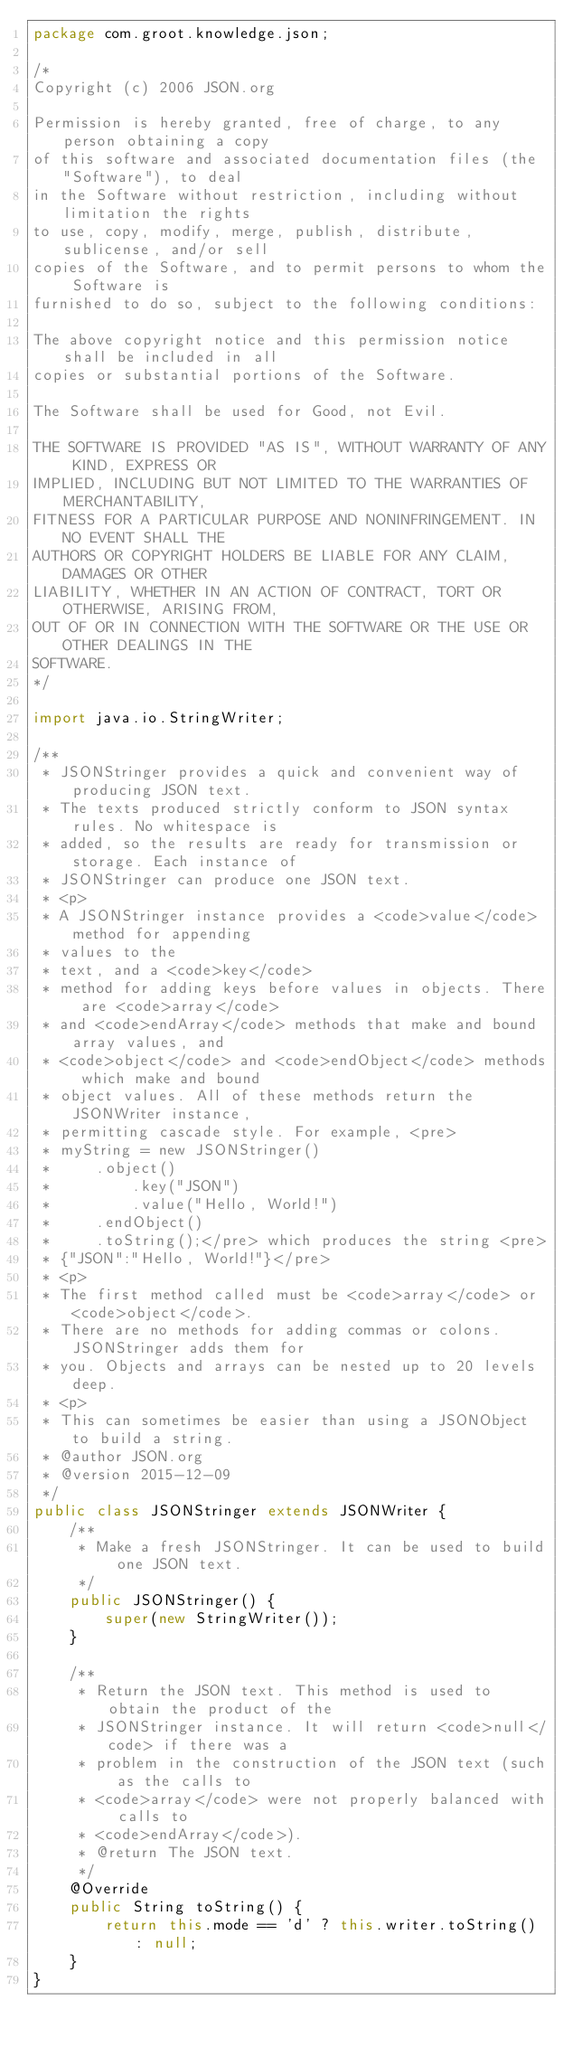<code> <loc_0><loc_0><loc_500><loc_500><_Java_>package com.groot.knowledge.json;

/*
Copyright (c) 2006 JSON.org

Permission is hereby granted, free of charge, to any person obtaining a copy
of this software and associated documentation files (the "Software"), to deal
in the Software without restriction, including without limitation the rights
to use, copy, modify, merge, publish, distribute, sublicense, and/or sell
copies of the Software, and to permit persons to whom the Software is
furnished to do so, subject to the following conditions:

The above copyright notice and this permission notice shall be included in all
copies or substantial portions of the Software.

The Software shall be used for Good, not Evil.

THE SOFTWARE IS PROVIDED "AS IS", WITHOUT WARRANTY OF ANY KIND, EXPRESS OR
IMPLIED, INCLUDING BUT NOT LIMITED TO THE WARRANTIES OF MERCHANTABILITY,
FITNESS FOR A PARTICULAR PURPOSE AND NONINFRINGEMENT. IN NO EVENT SHALL THE
AUTHORS OR COPYRIGHT HOLDERS BE LIABLE FOR ANY CLAIM, DAMAGES OR OTHER
LIABILITY, WHETHER IN AN ACTION OF CONTRACT, TORT OR OTHERWISE, ARISING FROM,
OUT OF OR IN CONNECTION WITH THE SOFTWARE OR THE USE OR OTHER DEALINGS IN THE
SOFTWARE.
*/

import java.io.StringWriter;

/**
 * JSONStringer provides a quick and convenient way of producing JSON text.
 * The texts produced strictly conform to JSON syntax rules. No whitespace is
 * added, so the results are ready for transmission or storage. Each instance of
 * JSONStringer can produce one JSON text.
 * <p>
 * A JSONStringer instance provides a <code>value</code> method for appending
 * values to the
 * text, and a <code>key</code>
 * method for adding keys before values in objects. There are <code>array</code>
 * and <code>endArray</code> methods that make and bound array values, and
 * <code>object</code> and <code>endObject</code> methods which make and bound
 * object values. All of these methods return the JSONWriter instance,
 * permitting cascade style. For example, <pre>
 * myString = new JSONStringer()
 *     .object()
 *         .key("JSON")
 *         .value("Hello, World!")
 *     .endObject()
 *     .toString();</pre> which produces the string <pre>
 * {"JSON":"Hello, World!"}</pre>
 * <p>
 * The first method called must be <code>array</code> or <code>object</code>.
 * There are no methods for adding commas or colons. JSONStringer adds them for
 * you. Objects and arrays can be nested up to 20 levels deep.
 * <p>
 * This can sometimes be easier than using a JSONObject to build a string.
 * @author JSON.org
 * @version 2015-12-09
 */
public class JSONStringer extends JSONWriter {
    /**
     * Make a fresh JSONStringer. It can be used to build one JSON text.
     */
    public JSONStringer() {
        super(new StringWriter());
    }

    /**
     * Return the JSON text. This method is used to obtain the product of the
     * JSONStringer instance. It will return <code>null</code> if there was a
     * problem in the construction of the JSON text (such as the calls to
     * <code>array</code> were not properly balanced with calls to
     * <code>endArray</code>).
     * @return The JSON text.
     */
    @Override
    public String toString() {
        return this.mode == 'd' ? this.writer.toString() : null;
    }
}
</code> 